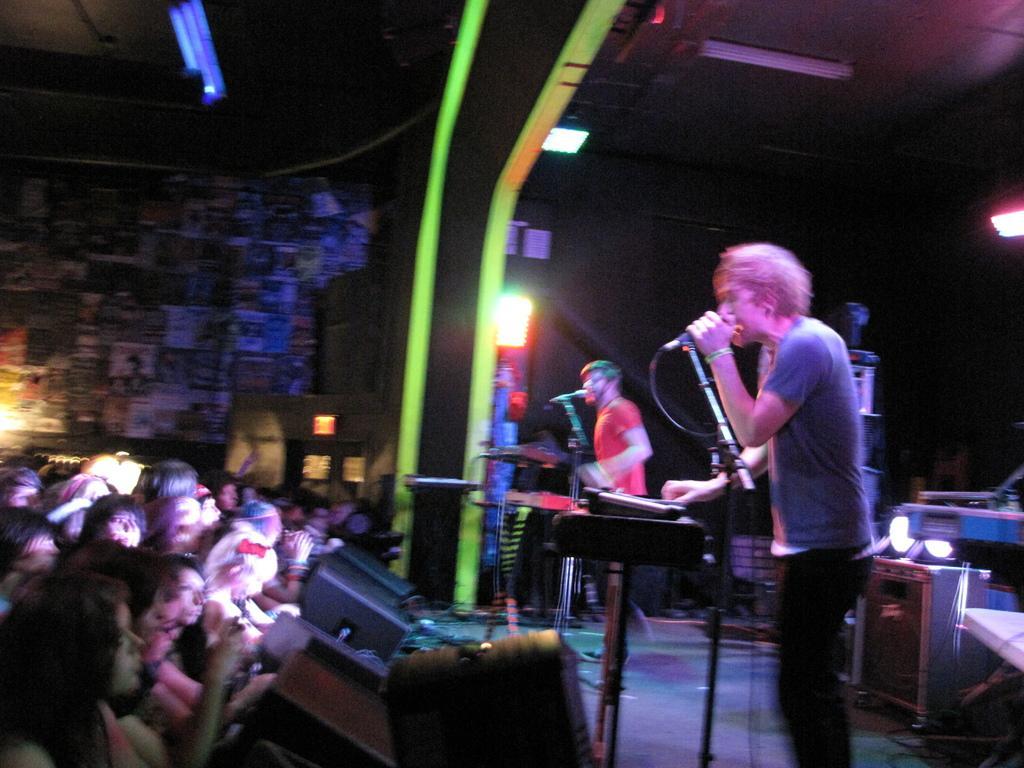In one or two sentences, can you explain what this image depicts? In the picture we can see two men are standing on the stage and singing songs in the microphone holding it and in front of them we can see some people are standing and watching them, and to the walls we can see posters. 